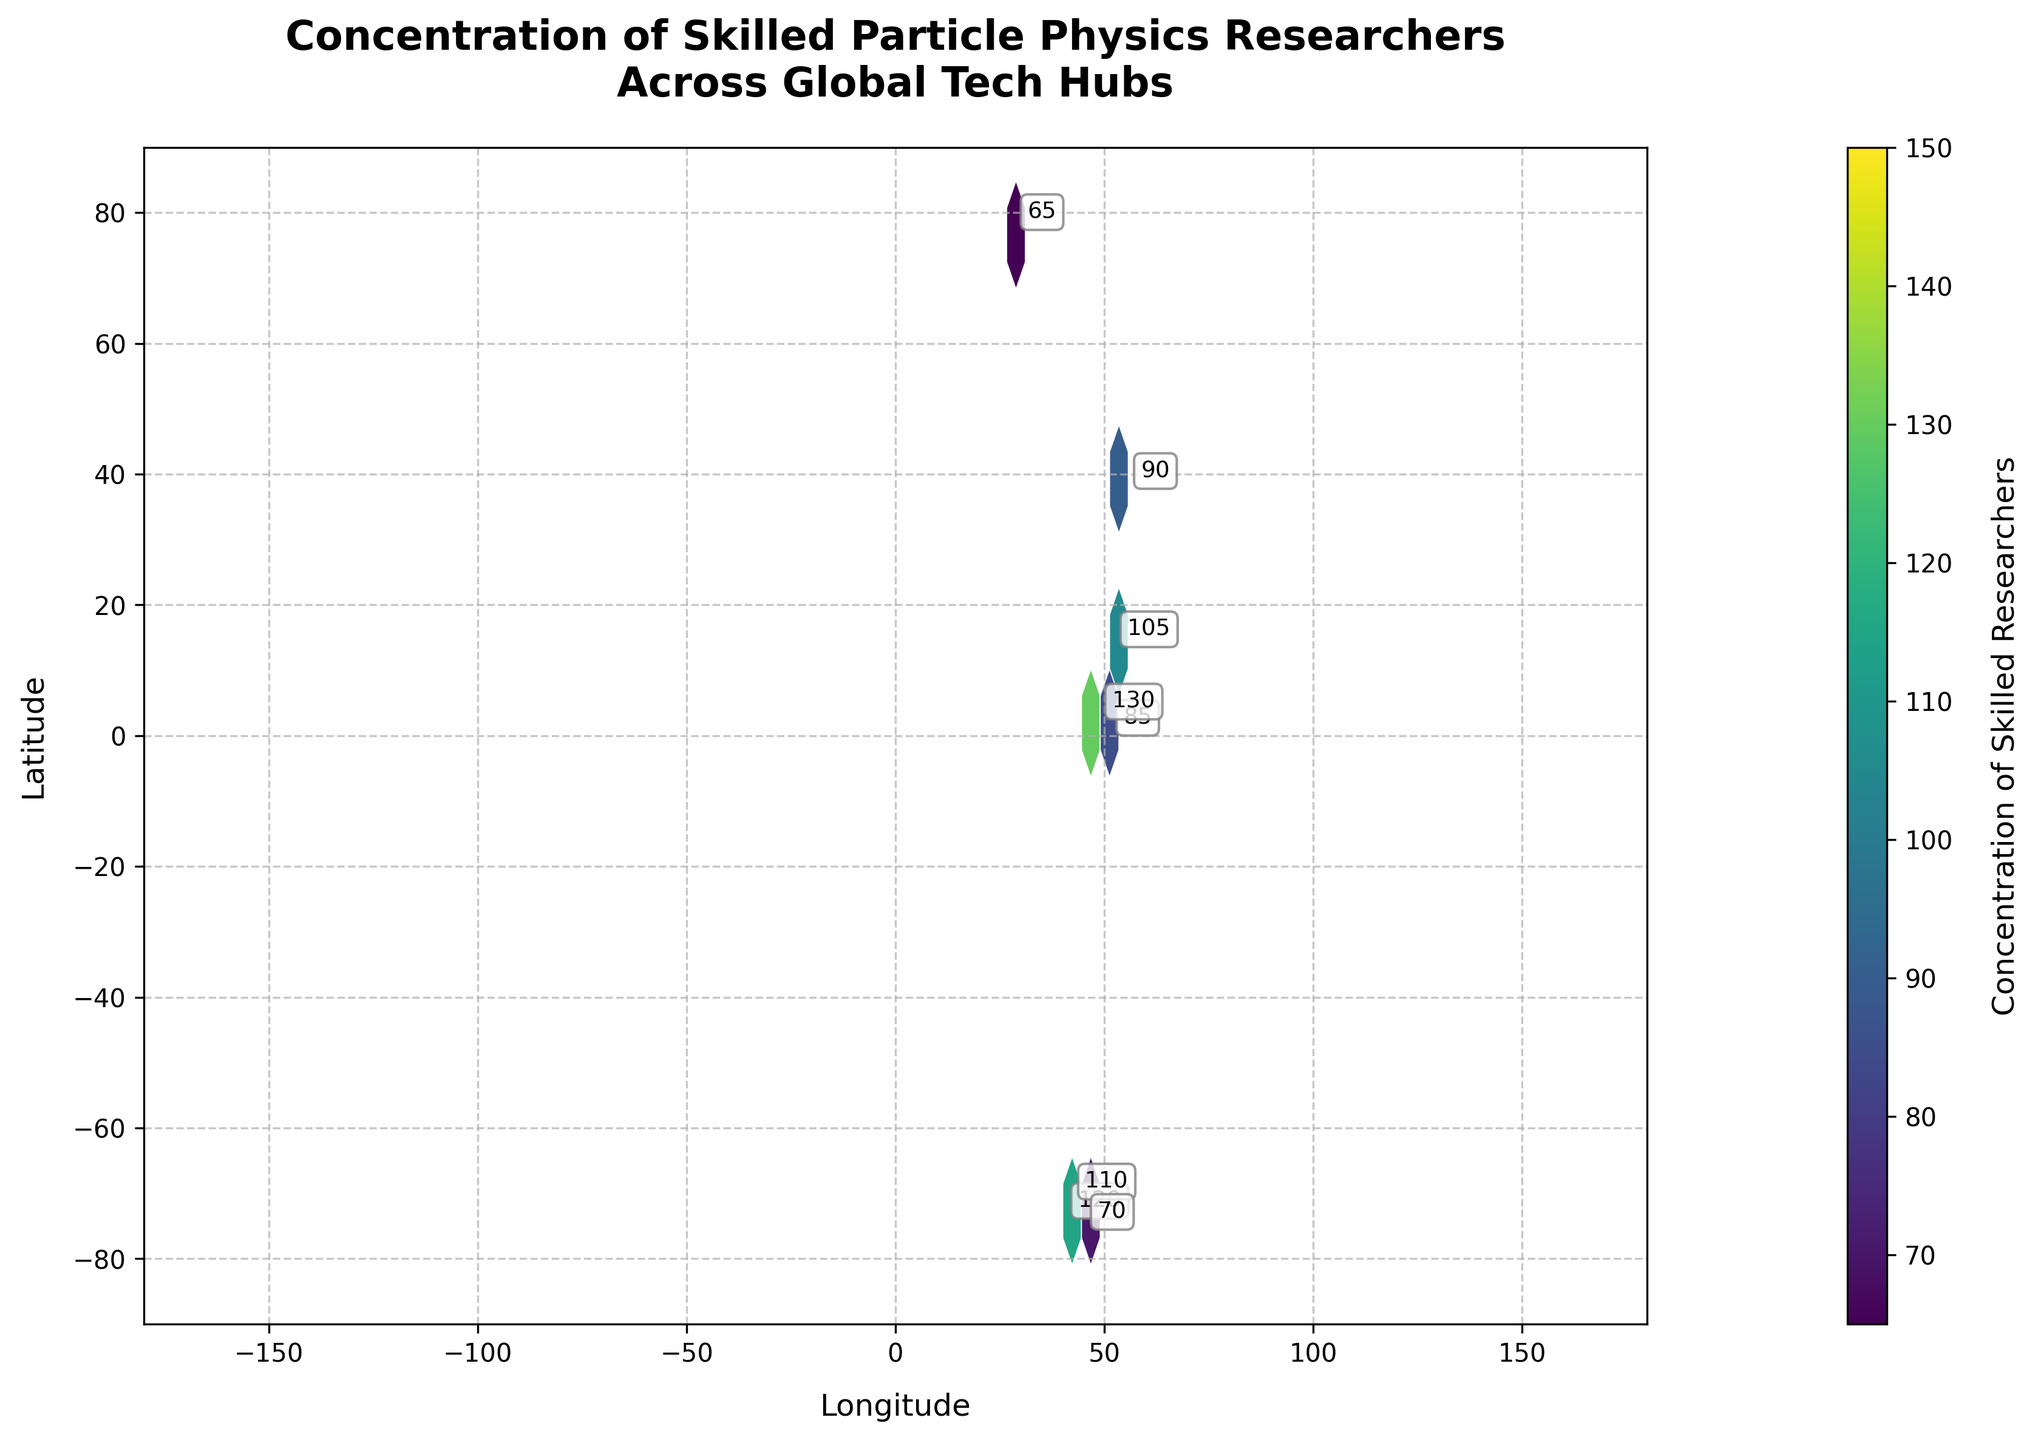What's the title of the figure? The title of a plot is typically displayed at the top of the figure, summarizing the key information about what is being depicted in the plot. For this Hexbin Plot, the title reads: 'Concentration of Skilled Particle Physics Researchers Across Global Tech Hubs'.
Answer: Concentration of Skilled Particle Physics Researchers Across Global Tech Hubs What does the color indicate in the figure? The color scale in a Hexbin Plot typically represents the density or concentration of the data points within each hexagon. In this figure, the color indicates the 'Concentration of Skilled Researchers,' with different shades likely corresponding to lower or higher concentrations. This is also confirmed by the color bar with the label 'Concentration of Skilled Researchers' located typically to the right of the plot.
Answer: Concentration of Skilled Researchers Which city has the highest concentration of skilled particle physics researchers? To find the highest concentration, you need to look for the darkest or most prominent hexagon in terms of color. According to the data points, the highest value is '150' which corresponds to the coordinates (37.7749, -122.4194), located in San Francisco, CA.
Answer: San Francisco, CA, USA How many tech hubs are shown in the plot? The plot displays one hexagon for each tech hub represented by the data points. By counting the number of data points or hexagons, we can determine the total number of tech hubs shown. According to the data, there are 15 different tech hubs.
Answer: 15 Are there more tech hubs in the Northern or Southern Hemisphere? The line that divides the Northern and Southern Hemispheres is the Equator (latitude = 0). By observing the plot, you simply count the number of points in each hemisphere. In the provided data, most points have positive latitudes, indicating they are in the Northern Hemisphere. Specifically, there are only two points in the Southern Hemisphere: Sydney and Singapore.
Answer: Northern Hemisphere What is the range of researcher concentrations across these tech hubs? The range is found by subtracting the smallest value from the largest value among the concentration data points. According to the data, the highest concentration is 150 and the lowest is 65. Therefore, the range is 150 - 65 = 85.
Answer: 85 Which tech hub has the lowest concentration of researchers? To identify the tech hub with the lowest concentration, look for the hexagon with the lightest color or the smallest value. According to the data, the lowest value of 65 corresponds to the coordinates (28.6139, 77.2090), which is New Delhi, India.
Answer: New Delhi, India What is the difference in researcher concentration between London and Paris? First, identify the concentration values for both cities. London has a concentration of 85, and Paris has a concentration of 130. The difference is calculated as 130 - 85 = 45.
Answer: 45 How does the concentration in Berlin compare to that in Tokyo? Compare the concentration values directly. Berlin has a concentration of 105, while Tokyo has a concentration of 140. Therefore, Tokyo has a higher concentration of skilled researchers than Berlin.
Answer: Tokyo has a higher concentration than Berlin Which hexagon bin size is used in the plot? The hexbin plot uses a specified grid size to aggregate data points within each hexagon. According to the code provided, the grid size in this plot is set to 20, giving us a sense of the spatial resolution used to aggregate the data.
Answer: 20 